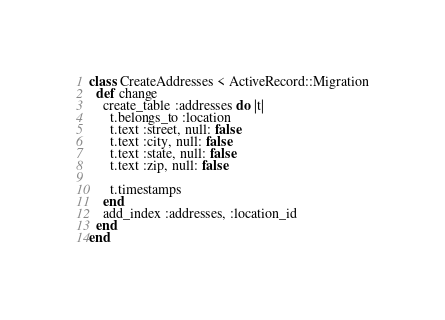Convert code to text. <code><loc_0><loc_0><loc_500><loc_500><_Ruby_>class CreateAddresses < ActiveRecord::Migration
  def change
    create_table :addresses do |t|
      t.belongs_to :location
      t.text :street, null: false
      t.text :city, null: false
      t.text :state, null: false
      t.text :zip, null: false

      t.timestamps
    end
    add_index :addresses, :location_id
  end
end
</code> 